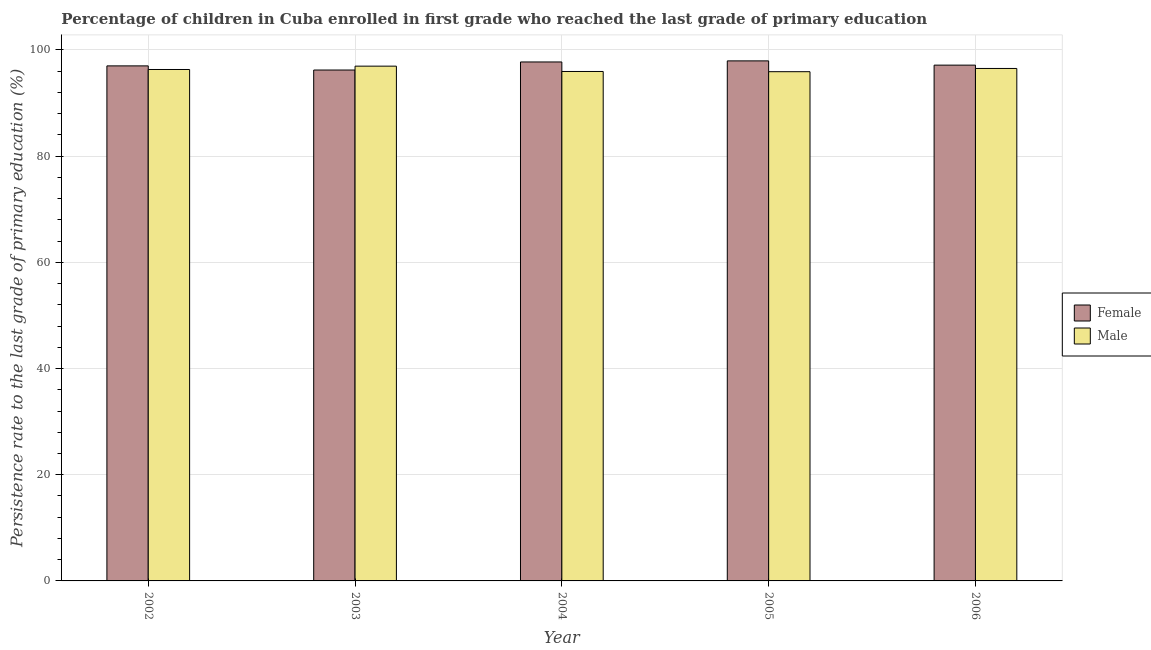How many different coloured bars are there?
Offer a terse response. 2. Are the number of bars on each tick of the X-axis equal?
Provide a succinct answer. Yes. How many bars are there on the 2nd tick from the left?
Your answer should be compact. 2. How many bars are there on the 3rd tick from the right?
Ensure brevity in your answer.  2. What is the label of the 3rd group of bars from the left?
Keep it short and to the point. 2004. What is the persistence rate of male students in 2003?
Ensure brevity in your answer.  96.95. Across all years, what is the maximum persistence rate of male students?
Your answer should be very brief. 96.95. Across all years, what is the minimum persistence rate of male students?
Keep it short and to the point. 95.9. In which year was the persistence rate of female students maximum?
Your answer should be compact. 2005. What is the total persistence rate of female students in the graph?
Your answer should be compact. 486.02. What is the difference between the persistence rate of female students in 2003 and that in 2005?
Your response must be concise. -1.72. What is the difference between the persistence rate of female students in 2006 and the persistence rate of male students in 2003?
Make the answer very short. 0.92. What is the average persistence rate of female students per year?
Ensure brevity in your answer.  97.2. In the year 2006, what is the difference between the persistence rate of male students and persistence rate of female students?
Keep it short and to the point. 0. In how many years, is the persistence rate of female students greater than 28 %?
Provide a succinct answer. 5. What is the ratio of the persistence rate of female students in 2002 to that in 2003?
Your answer should be compact. 1.01. Is the persistence rate of female students in 2002 less than that in 2005?
Your answer should be very brief. Yes. Is the difference between the persistence rate of female students in 2004 and 2006 greater than the difference between the persistence rate of male students in 2004 and 2006?
Provide a succinct answer. No. What is the difference between the highest and the second highest persistence rate of female students?
Your response must be concise. 0.2. What is the difference between the highest and the lowest persistence rate of female students?
Provide a short and direct response. 1.72. What does the 1st bar from the left in 2005 represents?
Give a very brief answer. Female. What does the 1st bar from the right in 2003 represents?
Provide a succinct answer. Male. Are all the bars in the graph horizontal?
Make the answer very short. No. How many years are there in the graph?
Provide a short and direct response. 5. What is the difference between two consecutive major ticks on the Y-axis?
Keep it short and to the point. 20. Are the values on the major ticks of Y-axis written in scientific E-notation?
Provide a short and direct response. No. Where does the legend appear in the graph?
Your response must be concise. Center right. What is the title of the graph?
Your response must be concise. Percentage of children in Cuba enrolled in first grade who reached the last grade of primary education. What is the label or title of the Y-axis?
Ensure brevity in your answer.  Persistence rate to the last grade of primary education (%). What is the Persistence rate to the last grade of primary education (%) of Female in 2002?
Offer a very short reply. 96.99. What is the Persistence rate to the last grade of primary education (%) of Male in 2002?
Offer a very short reply. 96.31. What is the Persistence rate to the last grade of primary education (%) of Female in 2003?
Offer a terse response. 96.21. What is the Persistence rate to the last grade of primary education (%) in Male in 2003?
Provide a short and direct response. 96.95. What is the Persistence rate to the last grade of primary education (%) in Female in 2004?
Make the answer very short. 97.73. What is the Persistence rate to the last grade of primary education (%) in Male in 2004?
Give a very brief answer. 95.94. What is the Persistence rate to the last grade of primary education (%) in Female in 2005?
Make the answer very short. 97.94. What is the Persistence rate to the last grade of primary education (%) in Male in 2005?
Provide a short and direct response. 95.9. What is the Persistence rate to the last grade of primary education (%) in Female in 2006?
Your answer should be very brief. 97.14. What is the Persistence rate to the last grade of primary education (%) in Male in 2006?
Offer a very short reply. 96.51. Across all years, what is the maximum Persistence rate to the last grade of primary education (%) of Female?
Keep it short and to the point. 97.94. Across all years, what is the maximum Persistence rate to the last grade of primary education (%) of Male?
Make the answer very short. 96.95. Across all years, what is the minimum Persistence rate to the last grade of primary education (%) in Female?
Make the answer very short. 96.21. Across all years, what is the minimum Persistence rate to the last grade of primary education (%) of Male?
Ensure brevity in your answer.  95.9. What is the total Persistence rate to the last grade of primary education (%) of Female in the graph?
Ensure brevity in your answer.  486.02. What is the total Persistence rate to the last grade of primary education (%) in Male in the graph?
Your response must be concise. 481.62. What is the difference between the Persistence rate to the last grade of primary education (%) in Female in 2002 and that in 2003?
Make the answer very short. 0.78. What is the difference between the Persistence rate to the last grade of primary education (%) in Male in 2002 and that in 2003?
Ensure brevity in your answer.  -0.63. What is the difference between the Persistence rate to the last grade of primary education (%) in Female in 2002 and that in 2004?
Your response must be concise. -0.74. What is the difference between the Persistence rate to the last grade of primary education (%) in Male in 2002 and that in 2004?
Provide a short and direct response. 0.37. What is the difference between the Persistence rate to the last grade of primary education (%) of Female in 2002 and that in 2005?
Give a very brief answer. -0.94. What is the difference between the Persistence rate to the last grade of primary education (%) of Male in 2002 and that in 2005?
Give a very brief answer. 0.41. What is the difference between the Persistence rate to the last grade of primary education (%) of Female in 2002 and that in 2006?
Provide a succinct answer. -0.14. What is the difference between the Persistence rate to the last grade of primary education (%) of Male in 2002 and that in 2006?
Your answer should be very brief. -0.2. What is the difference between the Persistence rate to the last grade of primary education (%) of Female in 2003 and that in 2004?
Ensure brevity in your answer.  -1.52. What is the difference between the Persistence rate to the last grade of primary education (%) in Female in 2003 and that in 2005?
Keep it short and to the point. -1.72. What is the difference between the Persistence rate to the last grade of primary education (%) in Male in 2003 and that in 2005?
Provide a short and direct response. 1.05. What is the difference between the Persistence rate to the last grade of primary education (%) of Female in 2003 and that in 2006?
Give a very brief answer. -0.92. What is the difference between the Persistence rate to the last grade of primary education (%) in Male in 2003 and that in 2006?
Provide a short and direct response. 0.44. What is the difference between the Persistence rate to the last grade of primary education (%) in Female in 2004 and that in 2005?
Your answer should be compact. -0.2. What is the difference between the Persistence rate to the last grade of primary education (%) in Male in 2004 and that in 2005?
Your response must be concise. 0.04. What is the difference between the Persistence rate to the last grade of primary education (%) of Female in 2004 and that in 2006?
Your answer should be very brief. 0.6. What is the difference between the Persistence rate to the last grade of primary education (%) in Male in 2004 and that in 2006?
Provide a succinct answer. -0.57. What is the difference between the Persistence rate to the last grade of primary education (%) in Female in 2005 and that in 2006?
Your answer should be very brief. 0.8. What is the difference between the Persistence rate to the last grade of primary education (%) in Male in 2005 and that in 2006?
Ensure brevity in your answer.  -0.61. What is the difference between the Persistence rate to the last grade of primary education (%) of Female in 2002 and the Persistence rate to the last grade of primary education (%) of Male in 2003?
Give a very brief answer. 0.05. What is the difference between the Persistence rate to the last grade of primary education (%) in Female in 2002 and the Persistence rate to the last grade of primary education (%) in Male in 2004?
Your answer should be compact. 1.05. What is the difference between the Persistence rate to the last grade of primary education (%) of Female in 2002 and the Persistence rate to the last grade of primary education (%) of Male in 2005?
Your response must be concise. 1.09. What is the difference between the Persistence rate to the last grade of primary education (%) of Female in 2002 and the Persistence rate to the last grade of primary education (%) of Male in 2006?
Your answer should be compact. 0.48. What is the difference between the Persistence rate to the last grade of primary education (%) of Female in 2003 and the Persistence rate to the last grade of primary education (%) of Male in 2004?
Your response must be concise. 0.27. What is the difference between the Persistence rate to the last grade of primary education (%) in Female in 2003 and the Persistence rate to the last grade of primary education (%) in Male in 2005?
Your answer should be compact. 0.31. What is the difference between the Persistence rate to the last grade of primary education (%) in Female in 2003 and the Persistence rate to the last grade of primary education (%) in Male in 2006?
Provide a short and direct response. -0.3. What is the difference between the Persistence rate to the last grade of primary education (%) of Female in 2004 and the Persistence rate to the last grade of primary education (%) of Male in 2005?
Provide a succinct answer. 1.83. What is the difference between the Persistence rate to the last grade of primary education (%) of Female in 2004 and the Persistence rate to the last grade of primary education (%) of Male in 2006?
Ensure brevity in your answer.  1.22. What is the difference between the Persistence rate to the last grade of primary education (%) in Female in 2005 and the Persistence rate to the last grade of primary education (%) in Male in 2006?
Your response must be concise. 1.43. What is the average Persistence rate to the last grade of primary education (%) of Female per year?
Your answer should be very brief. 97.2. What is the average Persistence rate to the last grade of primary education (%) in Male per year?
Offer a terse response. 96.32. In the year 2002, what is the difference between the Persistence rate to the last grade of primary education (%) in Female and Persistence rate to the last grade of primary education (%) in Male?
Ensure brevity in your answer.  0.68. In the year 2003, what is the difference between the Persistence rate to the last grade of primary education (%) of Female and Persistence rate to the last grade of primary education (%) of Male?
Offer a terse response. -0.73. In the year 2004, what is the difference between the Persistence rate to the last grade of primary education (%) in Female and Persistence rate to the last grade of primary education (%) in Male?
Offer a terse response. 1.79. In the year 2005, what is the difference between the Persistence rate to the last grade of primary education (%) of Female and Persistence rate to the last grade of primary education (%) of Male?
Give a very brief answer. 2.04. In the year 2006, what is the difference between the Persistence rate to the last grade of primary education (%) in Female and Persistence rate to the last grade of primary education (%) in Male?
Keep it short and to the point. 0.63. What is the ratio of the Persistence rate to the last grade of primary education (%) in Male in 2002 to that in 2003?
Your answer should be very brief. 0.99. What is the ratio of the Persistence rate to the last grade of primary education (%) of Female in 2002 to that in 2005?
Offer a terse response. 0.99. What is the ratio of the Persistence rate to the last grade of primary education (%) of Male in 2002 to that in 2005?
Provide a succinct answer. 1. What is the ratio of the Persistence rate to the last grade of primary education (%) of Female in 2002 to that in 2006?
Ensure brevity in your answer.  1. What is the ratio of the Persistence rate to the last grade of primary education (%) in Female in 2003 to that in 2004?
Offer a very short reply. 0.98. What is the ratio of the Persistence rate to the last grade of primary education (%) of Male in 2003 to that in 2004?
Offer a terse response. 1.01. What is the ratio of the Persistence rate to the last grade of primary education (%) in Female in 2003 to that in 2005?
Your answer should be very brief. 0.98. What is the ratio of the Persistence rate to the last grade of primary education (%) of Male in 2003 to that in 2005?
Provide a succinct answer. 1.01. What is the ratio of the Persistence rate to the last grade of primary education (%) of Male in 2003 to that in 2006?
Offer a terse response. 1. What is the ratio of the Persistence rate to the last grade of primary education (%) in Male in 2004 to that in 2005?
Give a very brief answer. 1. What is the ratio of the Persistence rate to the last grade of primary education (%) in Female in 2004 to that in 2006?
Keep it short and to the point. 1.01. What is the ratio of the Persistence rate to the last grade of primary education (%) in Female in 2005 to that in 2006?
Make the answer very short. 1.01. What is the ratio of the Persistence rate to the last grade of primary education (%) of Male in 2005 to that in 2006?
Offer a terse response. 0.99. What is the difference between the highest and the second highest Persistence rate to the last grade of primary education (%) of Female?
Provide a short and direct response. 0.2. What is the difference between the highest and the second highest Persistence rate to the last grade of primary education (%) in Male?
Keep it short and to the point. 0.44. What is the difference between the highest and the lowest Persistence rate to the last grade of primary education (%) in Female?
Offer a very short reply. 1.72. What is the difference between the highest and the lowest Persistence rate to the last grade of primary education (%) of Male?
Keep it short and to the point. 1.05. 